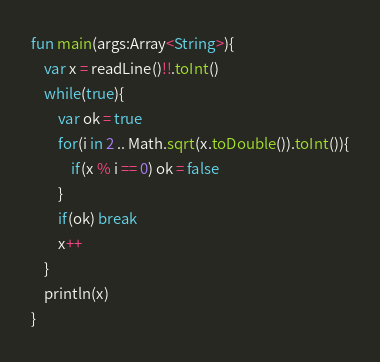Convert code to text. <code><loc_0><loc_0><loc_500><loc_500><_Kotlin_>fun main(args:Array<String>){
    var x = readLine()!!.toInt()
    while(true){
        var ok = true
        for(i in 2 .. Math.sqrt(x.toDouble()).toInt()){
            if(x % i == 0) ok = false
        }
        if(ok) break
        x++
    }
    println(x)
}
</code> 